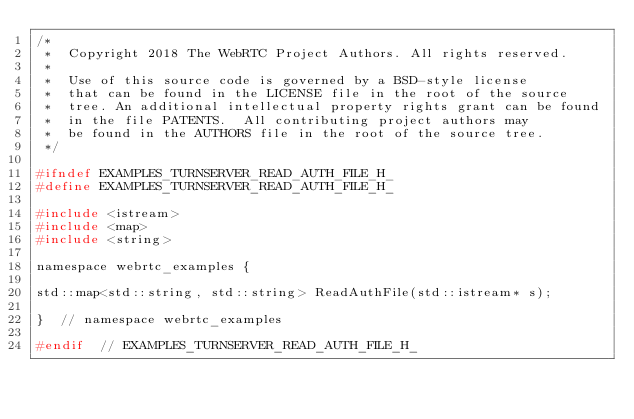Convert code to text. <code><loc_0><loc_0><loc_500><loc_500><_C_>/*
 *  Copyright 2018 The WebRTC Project Authors. All rights reserved.
 *
 *  Use of this source code is governed by a BSD-style license
 *  that can be found in the LICENSE file in the root of the source
 *  tree. An additional intellectual property rights grant can be found
 *  in the file PATENTS.  All contributing project authors may
 *  be found in the AUTHORS file in the root of the source tree.
 */

#ifndef EXAMPLES_TURNSERVER_READ_AUTH_FILE_H_
#define EXAMPLES_TURNSERVER_READ_AUTH_FILE_H_

#include <istream>
#include <map>
#include <string>

namespace webrtc_examples {

std::map<std::string, std::string> ReadAuthFile(std::istream* s);

}  // namespace webrtc_examples

#endif  // EXAMPLES_TURNSERVER_READ_AUTH_FILE_H_
</code> 